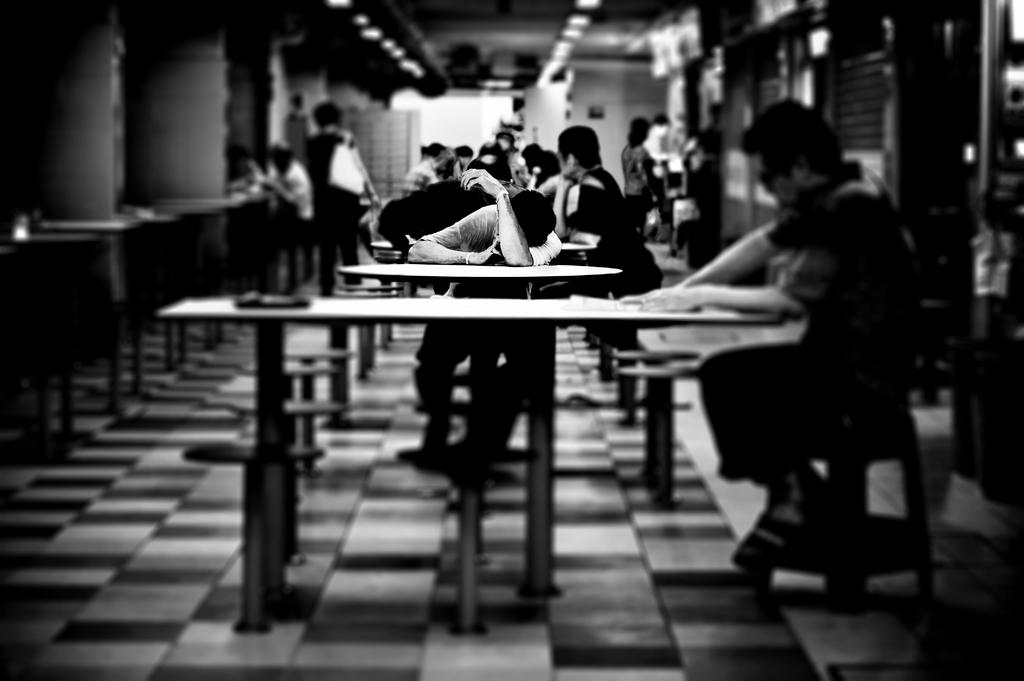What is present in the image that serves as a background or boundary? There is a wall in the image. What are the people in the image doing? Some people are standing, while others are sitting on chairs in the image. What piece of furniture is present in the image that can be used for placing objects? There is a table in the image. Is the representative giving a speech in the image? There is no representative or speech present in the image. Is the image taken during a rainy day? The image does not show any indication of rain, so it cannot be determined if the image was taken during a rainy day. 